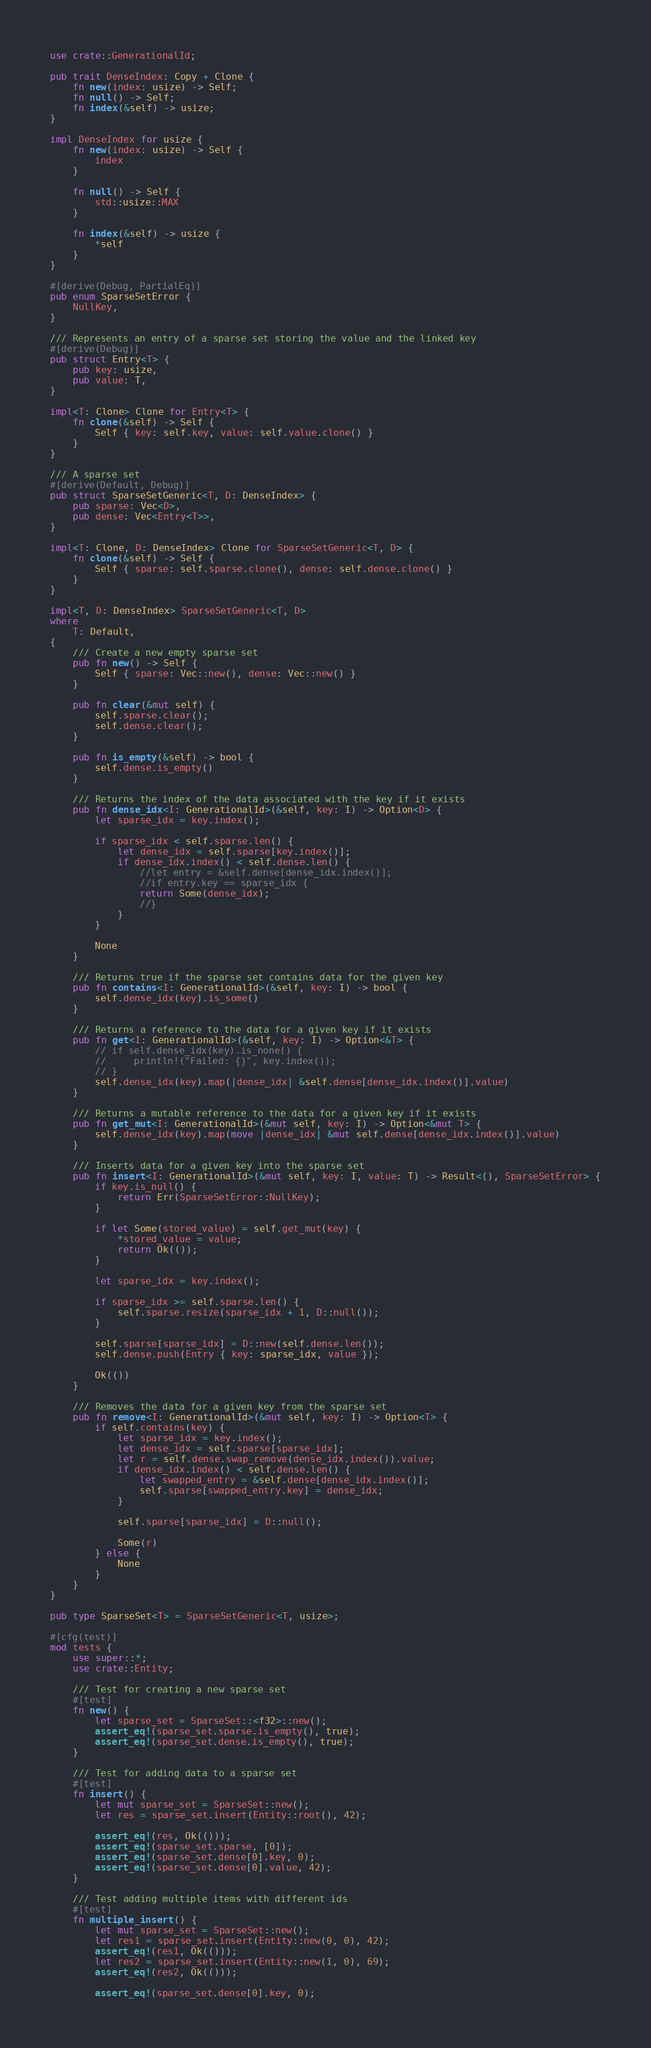Convert code to text. <code><loc_0><loc_0><loc_500><loc_500><_Rust_>use crate::GenerationalId;

pub trait DenseIndex: Copy + Clone {
    fn new(index: usize) -> Self;
    fn null() -> Self;
    fn index(&self) -> usize;
}

impl DenseIndex for usize {
    fn new(index: usize) -> Self {
        index
    }

    fn null() -> Self {
        std::usize::MAX
    }

    fn index(&self) -> usize {
        *self
    }
}

#[derive(Debug, PartialEq)]
pub enum SparseSetError {
    NullKey,
}

/// Represents an entry of a sparse set storing the value and the linked key
#[derive(Debug)]
pub struct Entry<T> {
    pub key: usize,
    pub value: T,
}

impl<T: Clone> Clone for Entry<T> {
    fn clone(&self) -> Self {
        Self { key: self.key, value: self.value.clone() }
    }
}

/// A sparse set
#[derive(Default, Debug)]
pub struct SparseSetGeneric<T, D: DenseIndex> {
    pub sparse: Vec<D>,
    pub dense: Vec<Entry<T>>,
}

impl<T: Clone, D: DenseIndex> Clone for SparseSetGeneric<T, D> {
    fn clone(&self) -> Self {
        Self { sparse: self.sparse.clone(), dense: self.dense.clone() }
    }
}

impl<T, D: DenseIndex> SparseSetGeneric<T, D>
where
    T: Default,
{
    /// Create a new empty sparse set
    pub fn new() -> Self {
        Self { sparse: Vec::new(), dense: Vec::new() }
    }

    pub fn clear(&mut self) {
        self.sparse.clear();
        self.dense.clear();
    }

    pub fn is_empty(&self) -> bool {
        self.dense.is_empty()
    }

    /// Returns the index of the data associated with the key if it exists
    pub fn dense_idx<I: GenerationalId>(&self, key: I) -> Option<D> {
        let sparse_idx = key.index();

        if sparse_idx < self.sparse.len() {
            let dense_idx = self.sparse[key.index()];
            if dense_idx.index() < self.dense.len() {
                //let entry = &self.dense[dense_idx.index()];
                //if entry.key == sparse_idx {
                return Some(dense_idx);
                //}
            }
        }

        None
    }

    /// Returns true if the sparse set contains data for the given key
    pub fn contains<I: GenerationalId>(&self, key: I) -> bool {
        self.dense_idx(key).is_some()
    }

    /// Returns a reference to the data for a given key if it exists
    pub fn get<I: GenerationalId>(&self, key: I) -> Option<&T> {
        // if self.dense_idx(key).is_none() {
        //     println!("Failed: {}", key.index());
        // }
        self.dense_idx(key).map(|dense_idx| &self.dense[dense_idx.index()].value)
    }

    /// Returns a mutable reference to the data for a given key if it exists
    pub fn get_mut<I: GenerationalId>(&mut self, key: I) -> Option<&mut T> {
        self.dense_idx(key).map(move |dense_idx| &mut self.dense[dense_idx.index()].value)
    }

    /// Inserts data for a given key into the sparse set
    pub fn insert<I: GenerationalId>(&mut self, key: I, value: T) -> Result<(), SparseSetError> {
        if key.is_null() {
            return Err(SparseSetError::NullKey);
        }

        if let Some(stored_value) = self.get_mut(key) {
            *stored_value = value;
            return Ok(());
        }

        let sparse_idx = key.index();

        if sparse_idx >= self.sparse.len() {
            self.sparse.resize(sparse_idx + 1, D::null());
        }

        self.sparse[sparse_idx] = D::new(self.dense.len());
        self.dense.push(Entry { key: sparse_idx, value });

        Ok(())
    }

    /// Removes the data for a given key from the sparse set
    pub fn remove<I: GenerationalId>(&mut self, key: I) -> Option<T> {
        if self.contains(key) {
            let sparse_idx = key.index();
            let dense_idx = self.sparse[sparse_idx];
            let r = self.dense.swap_remove(dense_idx.index()).value;
            if dense_idx.index() < self.dense.len() {
                let swapped_entry = &self.dense[dense_idx.index()];
                self.sparse[swapped_entry.key] = dense_idx;
            }

            self.sparse[sparse_idx] = D::null();

            Some(r)
        } else {
            None
        }
    }
}

pub type SparseSet<T> = SparseSetGeneric<T, usize>;

#[cfg(test)]
mod tests {
    use super::*;
    use crate::Entity;

    /// Test for creating a new sparse set
    #[test]
    fn new() {
        let sparse_set = SparseSet::<f32>::new();
        assert_eq!(sparse_set.sparse.is_empty(), true);
        assert_eq!(sparse_set.dense.is_empty(), true);
    }

    /// Test for adding data to a sparse set
    #[test]
    fn insert() {
        let mut sparse_set = SparseSet::new();
        let res = sparse_set.insert(Entity::root(), 42);

        assert_eq!(res, Ok(()));
        assert_eq!(sparse_set.sparse, [0]);
        assert_eq!(sparse_set.dense[0].key, 0);
        assert_eq!(sparse_set.dense[0].value, 42);
    }

    /// Test adding multiple items with different ids
    #[test]
    fn multiple_insert() {
        let mut sparse_set = SparseSet::new();
        let res1 = sparse_set.insert(Entity::new(0, 0), 42);
        assert_eq!(res1, Ok(()));
        let res2 = sparse_set.insert(Entity::new(1, 0), 69);
        assert_eq!(res2, Ok(()));

        assert_eq!(sparse_set.dense[0].key, 0);</code> 